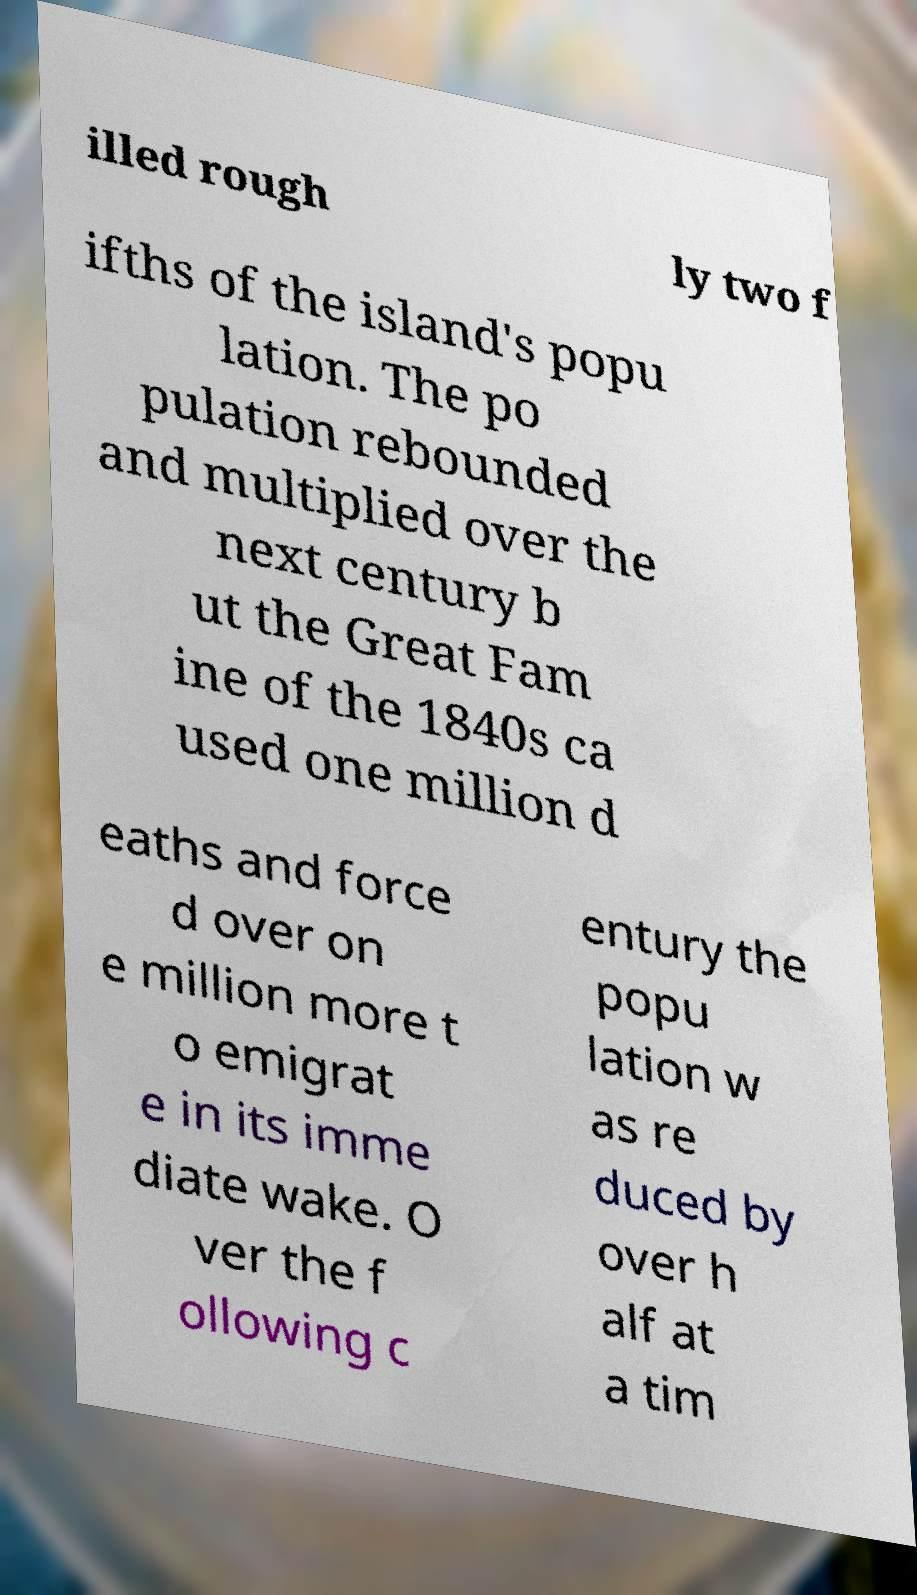What messages or text are displayed in this image? I need them in a readable, typed format. illed rough ly two f ifths of the island's popu lation. The po pulation rebounded and multiplied over the next century b ut the Great Fam ine of the 1840s ca used one million d eaths and force d over on e million more t o emigrat e in its imme diate wake. O ver the f ollowing c entury the popu lation w as re duced by over h alf at a tim 